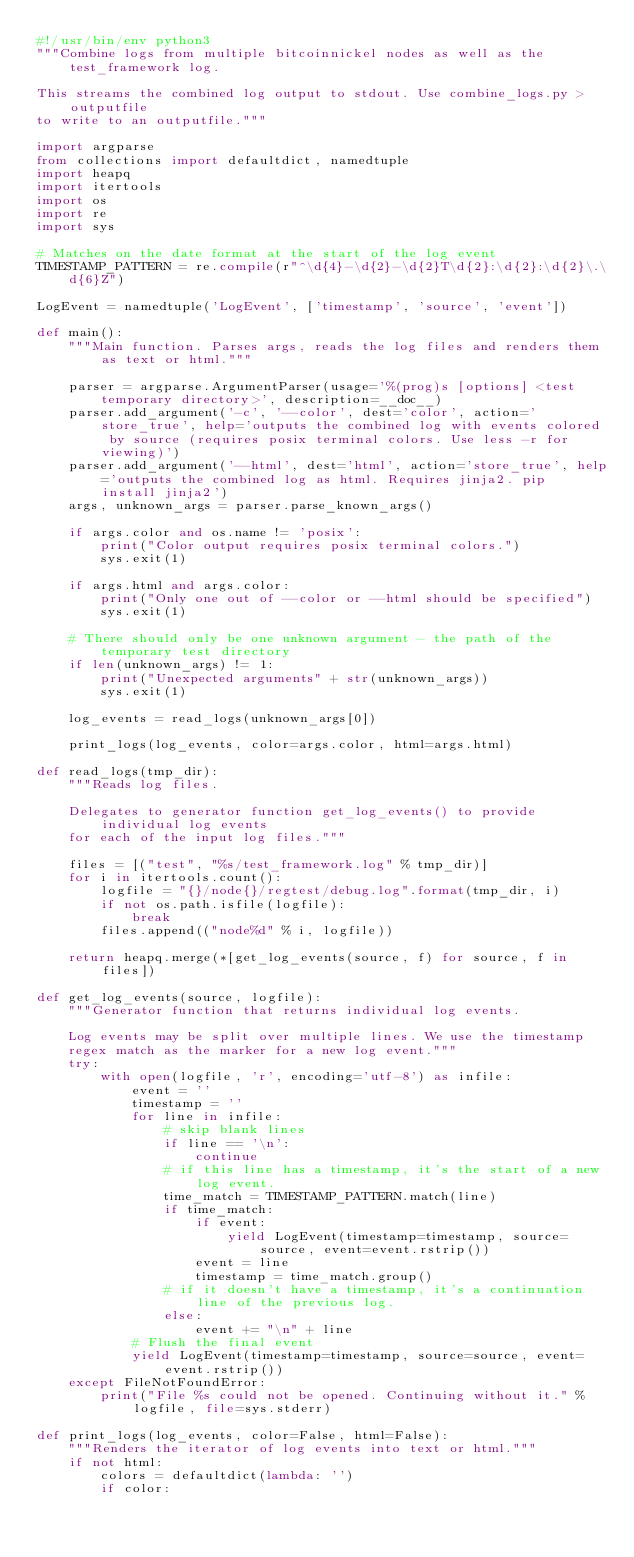Convert code to text. <code><loc_0><loc_0><loc_500><loc_500><_Python_>#!/usr/bin/env python3
"""Combine logs from multiple bitcoinnickel nodes as well as the test_framework log.

This streams the combined log output to stdout. Use combine_logs.py > outputfile
to write to an outputfile."""

import argparse
from collections import defaultdict, namedtuple
import heapq
import itertools
import os
import re
import sys

# Matches on the date format at the start of the log event
TIMESTAMP_PATTERN = re.compile(r"^\d{4}-\d{2}-\d{2}T\d{2}:\d{2}:\d{2}\.\d{6}Z")

LogEvent = namedtuple('LogEvent', ['timestamp', 'source', 'event'])

def main():
    """Main function. Parses args, reads the log files and renders them as text or html."""

    parser = argparse.ArgumentParser(usage='%(prog)s [options] <test temporary directory>', description=__doc__)
    parser.add_argument('-c', '--color', dest='color', action='store_true', help='outputs the combined log with events colored by source (requires posix terminal colors. Use less -r for viewing)')
    parser.add_argument('--html', dest='html', action='store_true', help='outputs the combined log as html. Requires jinja2. pip install jinja2')
    args, unknown_args = parser.parse_known_args()

    if args.color and os.name != 'posix':
        print("Color output requires posix terminal colors.")
        sys.exit(1)

    if args.html and args.color:
        print("Only one out of --color or --html should be specified")
        sys.exit(1)

    # There should only be one unknown argument - the path of the temporary test directory
    if len(unknown_args) != 1:
        print("Unexpected arguments" + str(unknown_args))
        sys.exit(1)

    log_events = read_logs(unknown_args[0])

    print_logs(log_events, color=args.color, html=args.html)

def read_logs(tmp_dir):
    """Reads log files.

    Delegates to generator function get_log_events() to provide individual log events
    for each of the input log files."""

    files = [("test", "%s/test_framework.log" % tmp_dir)]
    for i in itertools.count():
        logfile = "{}/node{}/regtest/debug.log".format(tmp_dir, i)
        if not os.path.isfile(logfile):
            break
        files.append(("node%d" % i, logfile))

    return heapq.merge(*[get_log_events(source, f) for source, f in files])

def get_log_events(source, logfile):
    """Generator function that returns individual log events.

    Log events may be split over multiple lines. We use the timestamp
    regex match as the marker for a new log event."""
    try:
        with open(logfile, 'r', encoding='utf-8') as infile:
            event = ''
            timestamp = ''
            for line in infile:
                # skip blank lines
                if line == '\n':
                    continue
                # if this line has a timestamp, it's the start of a new log event.
                time_match = TIMESTAMP_PATTERN.match(line)
                if time_match:
                    if event:
                        yield LogEvent(timestamp=timestamp, source=source, event=event.rstrip())
                    event = line
                    timestamp = time_match.group()
                # if it doesn't have a timestamp, it's a continuation line of the previous log.
                else:
                    event += "\n" + line
            # Flush the final event
            yield LogEvent(timestamp=timestamp, source=source, event=event.rstrip())
    except FileNotFoundError:
        print("File %s could not be opened. Continuing without it." % logfile, file=sys.stderr)

def print_logs(log_events, color=False, html=False):
    """Renders the iterator of log events into text or html."""
    if not html:
        colors = defaultdict(lambda: '')
        if color:</code> 